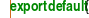Convert code to text. <code><loc_0><loc_0><loc_500><loc_500><_JavaScript_>
export default{</code> 